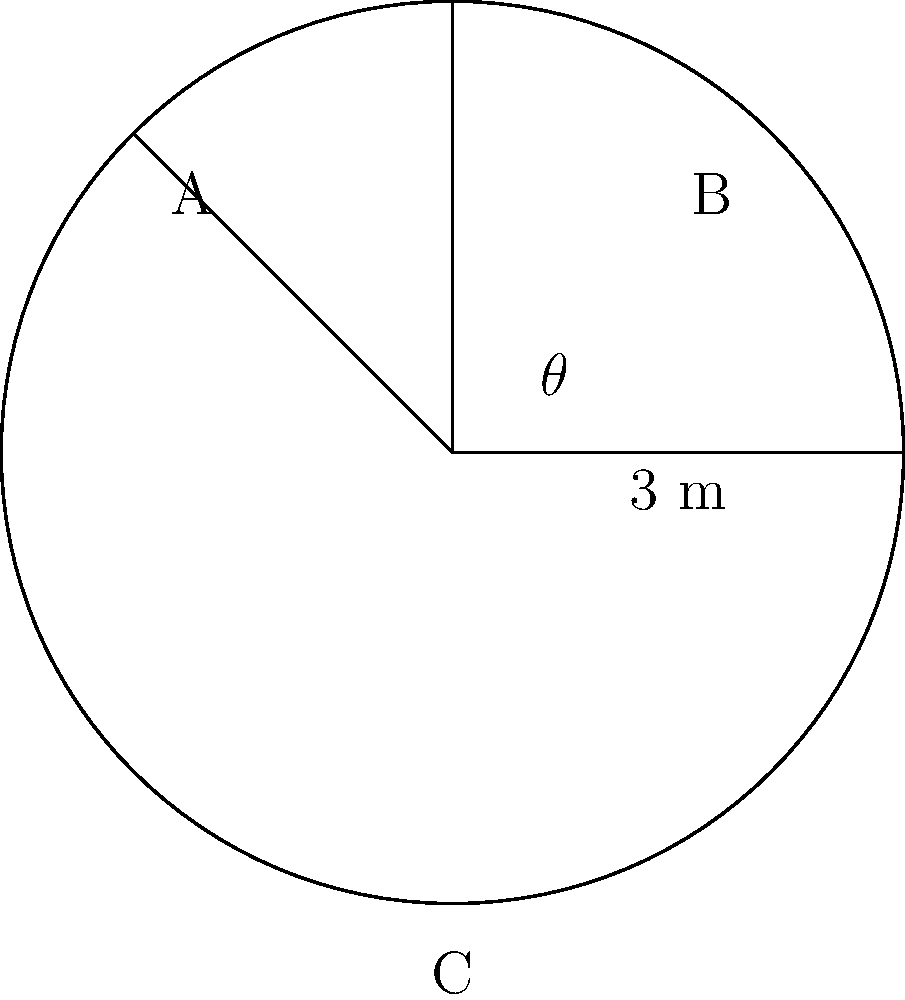An ancient circular stone calendar has been discovered in a remote archaeological site. The calendar is divided into three equal sectors, each representing a season. If the radius of the calendar is 3 meters, what is the area of one sector (representing one season) in square meters? Round your answer to two decimal places. To solve this problem, we need to follow these steps:

1) First, we need to understand that the circle is divided into three equal sectors, so each sector represents $\frac{1}{3}$ of the circle.

2) The area of a sector is given by the formula:

   $A_{sector} = \frac{1}{2}r^2\theta$

   Where $r$ is the radius and $\theta$ is the angle in radians.

3) We know the radius is 3 meters. For the angle, since the circle is divided into three equal parts, each sector has an angle of $\frac{2\pi}{3}$ radians (or 120°).

4) Let's substitute these values into our formula:

   $A_{sector} = \frac{1}{2} \cdot 3^2 \cdot \frac{2\pi}{3}$

5) Simplify:
   
   $A_{sector} = \frac{1}{2} \cdot 9 \cdot \frac{2\pi}{3} = 3\pi$ square meters

6) Rounding to two decimal places:

   $A_{sector} \approx 9.42$ square meters

Therefore, the area of one sector (representing one season) is approximately 9.42 square meters.
Answer: 9.42 m² 